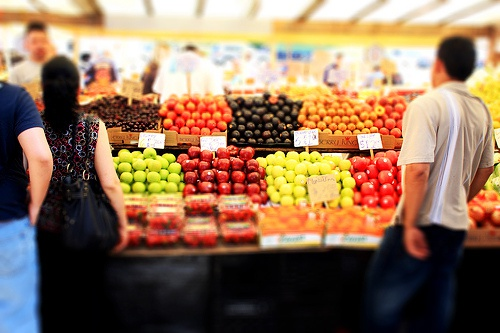Describe the objects in this image and their specific colors. I can see people in lightyellow, black, tan, lightgray, and darkgray tones, people in lightyellow, black, tan, and maroon tones, people in lightyellow, lightblue, black, navy, and salmon tones, handbag in lightyellow, black, maroon, gray, and brown tones, and apple in lightyellow, red, brown, maroon, and salmon tones in this image. 